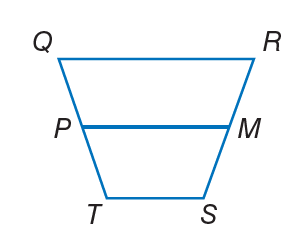Answer the mathemtical geometry problem and directly provide the correct option letter.
Question: For trapezoid Q R S T, M and P are midpoints of the legs. If T S = 2 x, P M = 20, and Q R = 6 x, find x.
Choices: A: 5 B: 10 C: 15 D: 30 A 